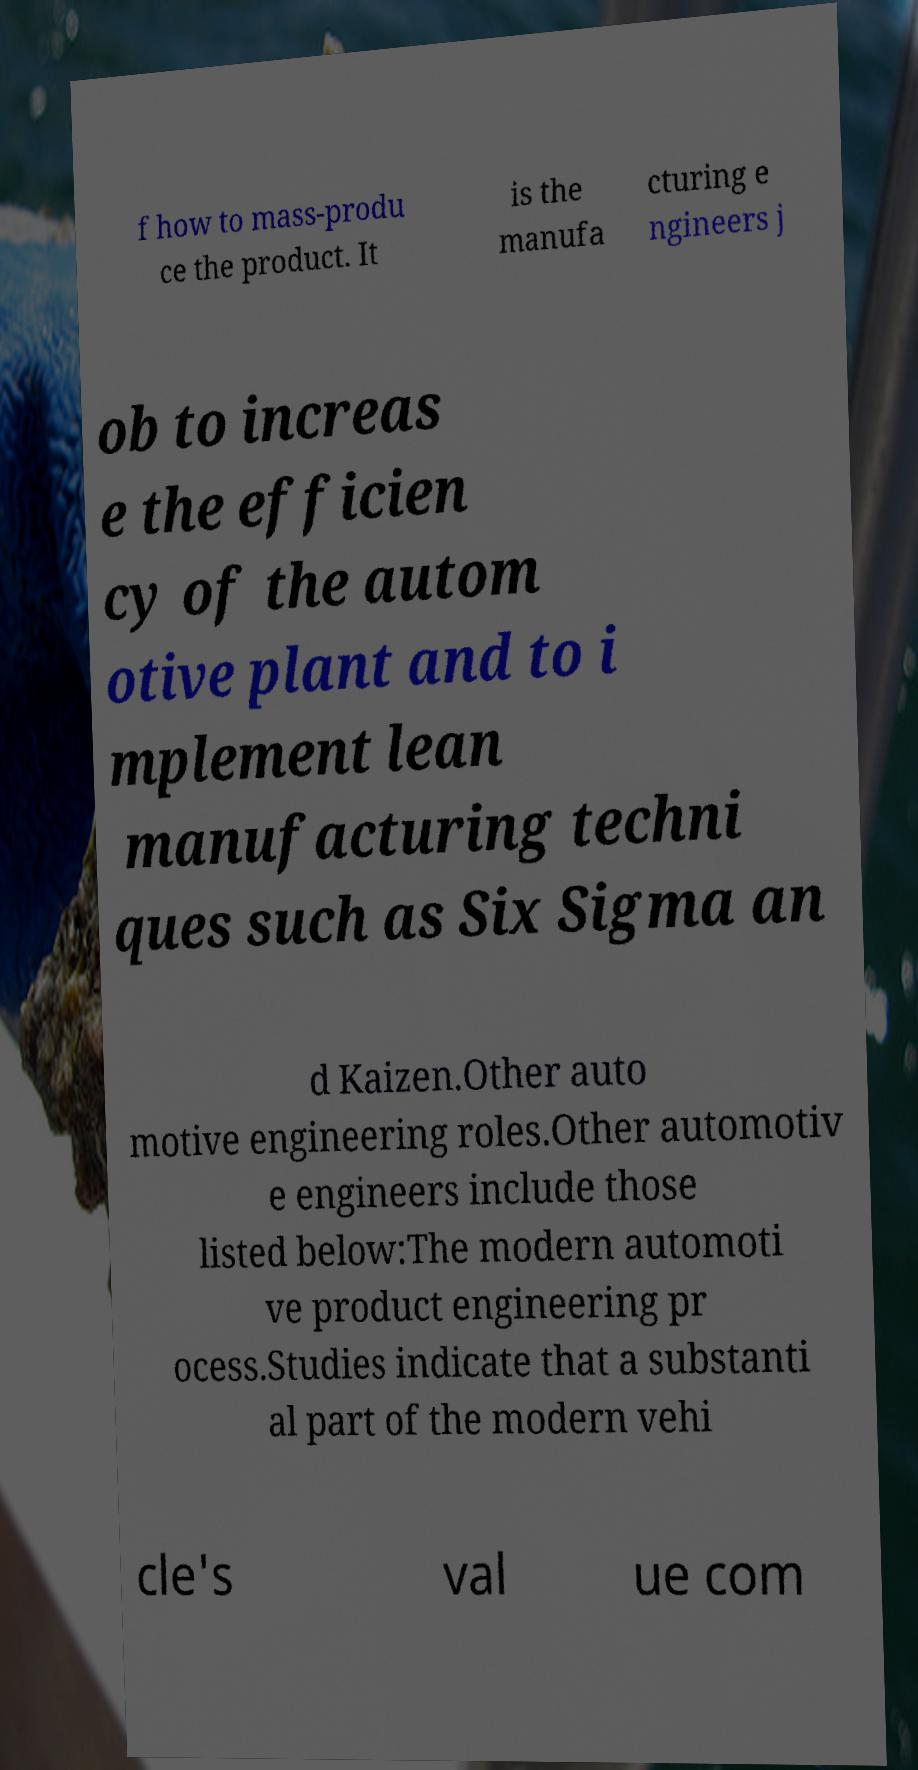There's text embedded in this image that I need extracted. Can you transcribe it verbatim? f how to mass-produ ce the product. It is the manufa cturing e ngineers j ob to increas e the efficien cy of the autom otive plant and to i mplement lean manufacturing techni ques such as Six Sigma an d Kaizen.Other auto motive engineering roles.Other automotiv e engineers include those listed below:The modern automoti ve product engineering pr ocess.Studies indicate that a substanti al part of the modern vehi cle's val ue com 